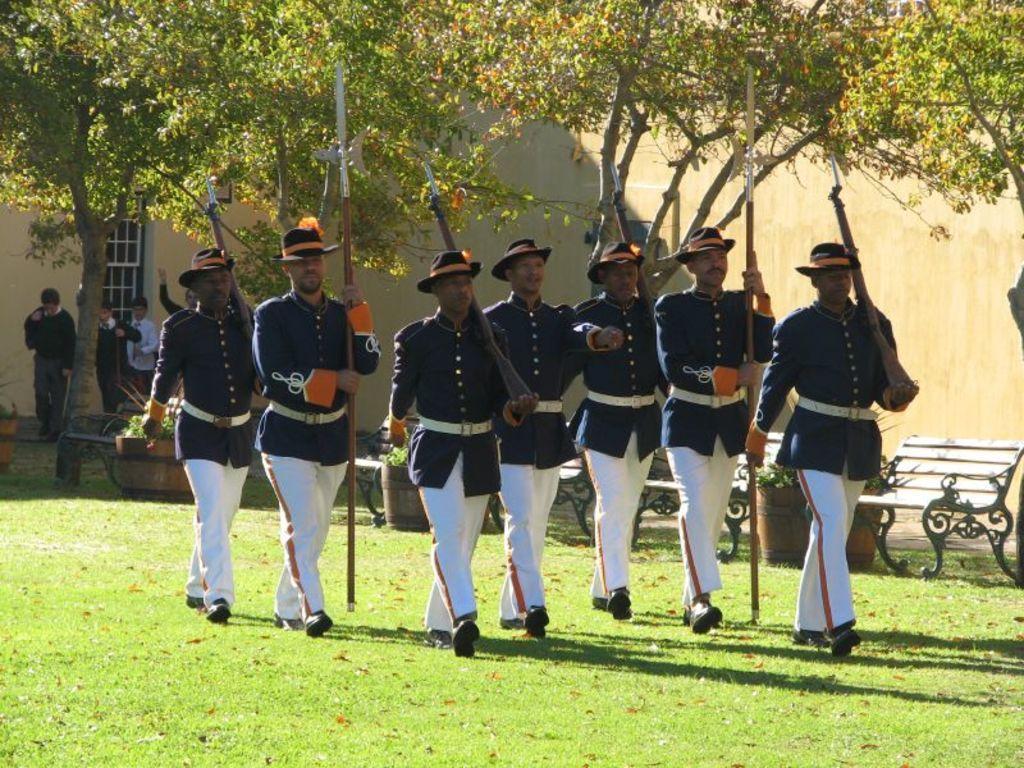Can you describe this image briefly? Here people are walking holding sticks, these are trees and benches, this is grass. 